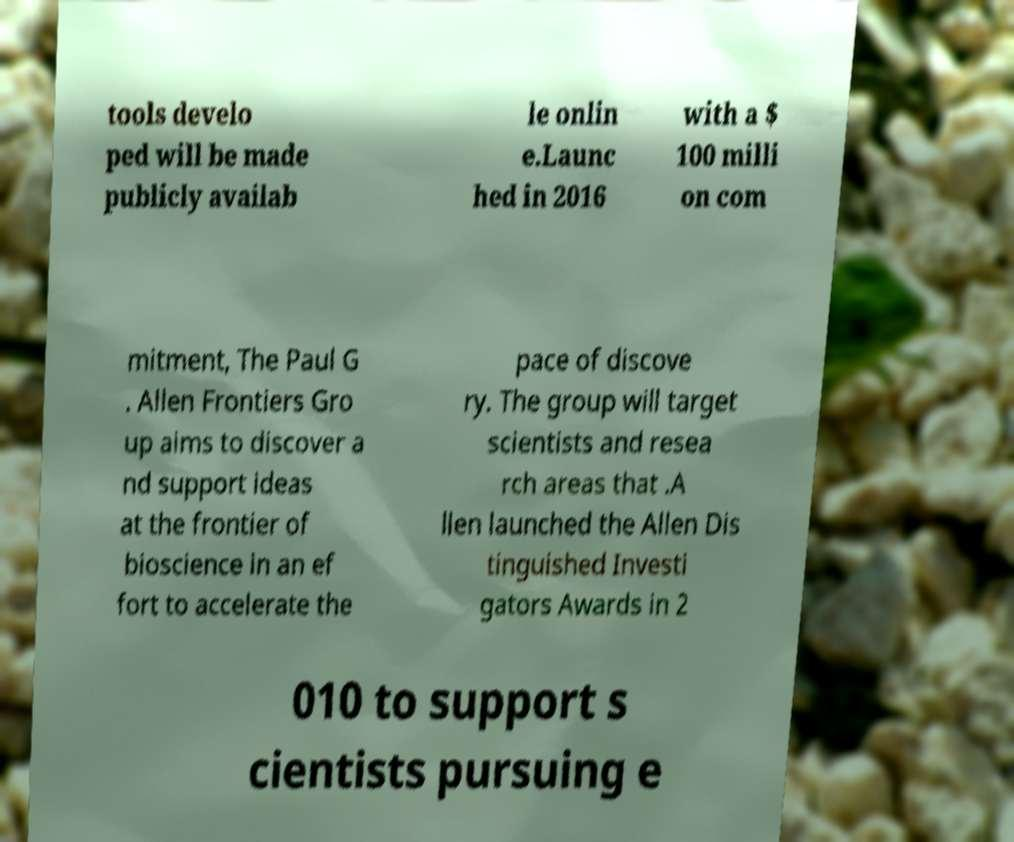There's text embedded in this image that I need extracted. Can you transcribe it verbatim? tools develo ped will be made publicly availab le onlin e.Launc hed in 2016 with a $ 100 milli on com mitment, The Paul G . Allen Frontiers Gro up aims to discover a nd support ideas at the frontier of bioscience in an ef fort to accelerate the pace of discove ry. The group will target scientists and resea rch areas that .A llen launched the Allen Dis tinguished Investi gators Awards in 2 010 to support s cientists pursuing e 